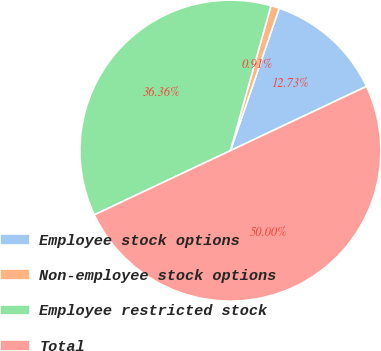Convert chart. <chart><loc_0><loc_0><loc_500><loc_500><pie_chart><fcel>Employee stock options<fcel>Non-employee stock options<fcel>Employee restricted stock<fcel>Total<nl><fcel>12.73%<fcel>0.91%<fcel>36.36%<fcel>50.0%<nl></chart> 